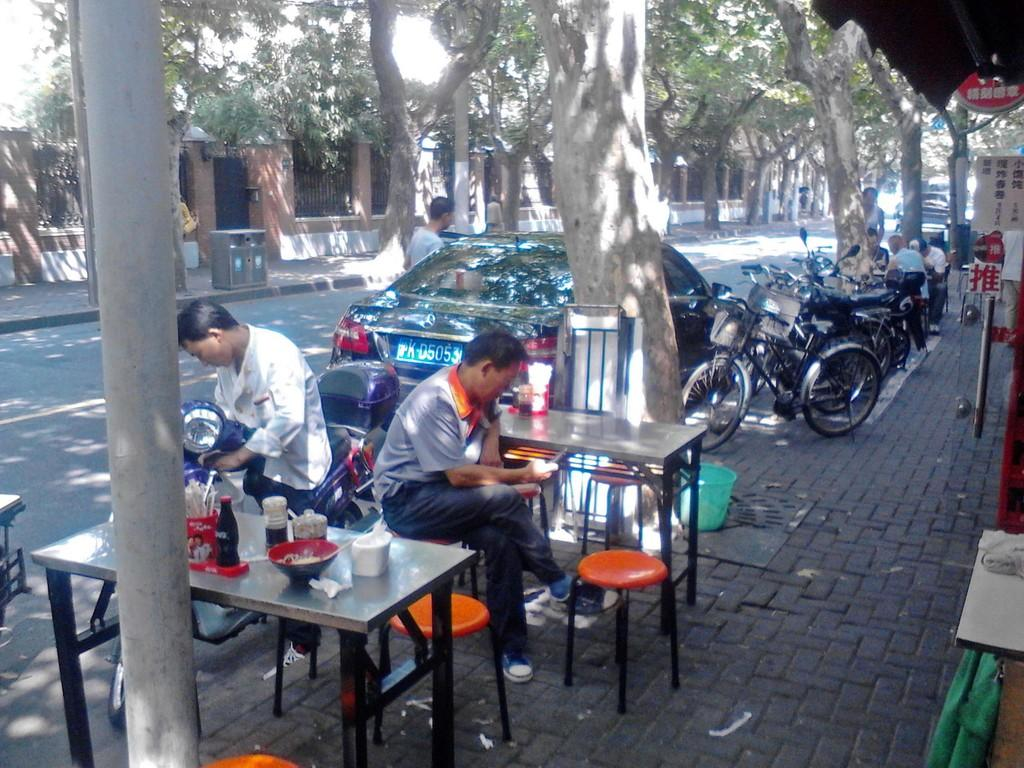What type of buildings can be seen in the image? There are houses in the image. What natural elements are present in the image? There are trees in the image. What are the people in the image doing? The people are sitting in the image. What vehicles are visible in the image? There is a car, a bicycle, and a motorcycle in the image. What type of furniture is present in the image? There are chairs and tables in the image. What items can be seen on the tables in the image? There is a bottle and a cup on a table in the image. What type of gate is present in the image? There is no gate present in the image. What process is being carried out by the porter in the image? There is no porter present in the image, and therefore no such process can be observed. 